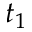<formula> <loc_0><loc_0><loc_500><loc_500>t _ { 1 }</formula> 